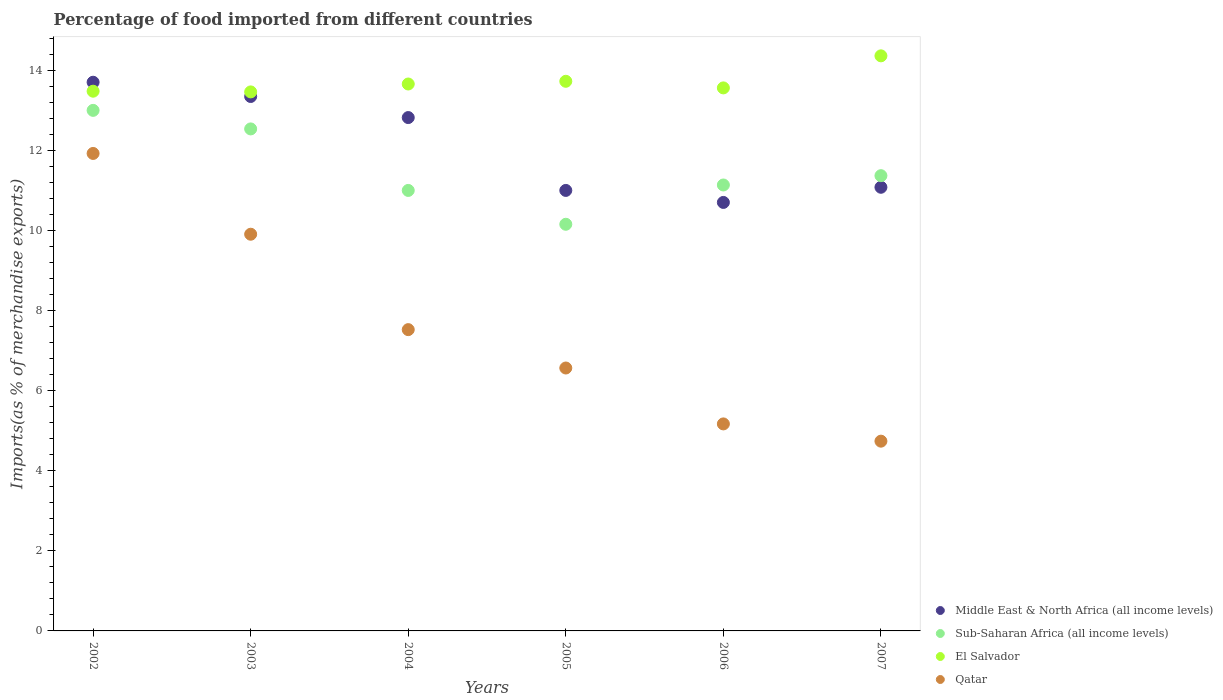How many different coloured dotlines are there?
Your response must be concise. 4. Is the number of dotlines equal to the number of legend labels?
Give a very brief answer. Yes. What is the percentage of imports to different countries in Sub-Saharan Africa (all income levels) in 2003?
Ensure brevity in your answer.  12.55. Across all years, what is the maximum percentage of imports to different countries in Middle East & North Africa (all income levels)?
Provide a short and direct response. 13.72. Across all years, what is the minimum percentage of imports to different countries in Sub-Saharan Africa (all income levels)?
Give a very brief answer. 10.17. What is the total percentage of imports to different countries in Middle East & North Africa (all income levels) in the graph?
Keep it short and to the point. 72.73. What is the difference between the percentage of imports to different countries in Sub-Saharan Africa (all income levels) in 2005 and that in 2007?
Keep it short and to the point. -1.21. What is the difference between the percentage of imports to different countries in Sub-Saharan Africa (all income levels) in 2004 and the percentage of imports to different countries in Qatar in 2003?
Ensure brevity in your answer.  1.1. What is the average percentage of imports to different countries in Qatar per year?
Your response must be concise. 7.65. In the year 2003, what is the difference between the percentage of imports to different countries in Qatar and percentage of imports to different countries in Sub-Saharan Africa (all income levels)?
Provide a short and direct response. -2.63. What is the ratio of the percentage of imports to different countries in El Salvador in 2004 to that in 2006?
Your answer should be very brief. 1.01. Is the difference between the percentage of imports to different countries in Qatar in 2002 and 2004 greater than the difference between the percentage of imports to different countries in Sub-Saharan Africa (all income levels) in 2002 and 2004?
Keep it short and to the point. Yes. What is the difference between the highest and the second highest percentage of imports to different countries in Qatar?
Your answer should be very brief. 2.02. What is the difference between the highest and the lowest percentage of imports to different countries in Qatar?
Provide a short and direct response. 7.19. Is it the case that in every year, the sum of the percentage of imports to different countries in El Salvador and percentage of imports to different countries in Sub-Saharan Africa (all income levels)  is greater than the sum of percentage of imports to different countries in Qatar and percentage of imports to different countries in Middle East & North Africa (all income levels)?
Ensure brevity in your answer.  No. Is it the case that in every year, the sum of the percentage of imports to different countries in Sub-Saharan Africa (all income levels) and percentage of imports to different countries in Middle East & North Africa (all income levels)  is greater than the percentage of imports to different countries in Qatar?
Offer a terse response. Yes. Does the percentage of imports to different countries in El Salvador monotonically increase over the years?
Make the answer very short. No. How many dotlines are there?
Your answer should be compact. 4. What is the difference between two consecutive major ticks on the Y-axis?
Offer a terse response. 2. Does the graph contain any zero values?
Provide a short and direct response. No. Where does the legend appear in the graph?
Your response must be concise. Bottom right. What is the title of the graph?
Provide a succinct answer. Percentage of food imported from different countries. Does "Brazil" appear as one of the legend labels in the graph?
Your response must be concise. No. What is the label or title of the Y-axis?
Give a very brief answer. Imports(as % of merchandise exports). What is the Imports(as % of merchandise exports) in Middle East & North Africa (all income levels) in 2002?
Your answer should be compact. 13.72. What is the Imports(as % of merchandise exports) of Sub-Saharan Africa (all income levels) in 2002?
Keep it short and to the point. 13.01. What is the Imports(as % of merchandise exports) in El Salvador in 2002?
Provide a short and direct response. 13.49. What is the Imports(as % of merchandise exports) in Qatar in 2002?
Your answer should be very brief. 11.94. What is the Imports(as % of merchandise exports) in Middle East & North Africa (all income levels) in 2003?
Give a very brief answer. 13.36. What is the Imports(as % of merchandise exports) of Sub-Saharan Africa (all income levels) in 2003?
Your answer should be very brief. 12.55. What is the Imports(as % of merchandise exports) of El Salvador in 2003?
Make the answer very short. 13.48. What is the Imports(as % of merchandise exports) in Qatar in 2003?
Offer a terse response. 9.92. What is the Imports(as % of merchandise exports) in Middle East & North Africa (all income levels) in 2004?
Provide a short and direct response. 12.83. What is the Imports(as % of merchandise exports) of Sub-Saharan Africa (all income levels) in 2004?
Provide a succinct answer. 11.01. What is the Imports(as % of merchandise exports) in El Salvador in 2004?
Provide a succinct answer. 13.67. What is the Imports(as % of merchandise exports) in Qatar in 2004?
Give a very brief answer. 7.53. What is the Imports(as % of merchandise exports) of Middle East & North Africa (all income levels) in 2005?
Give a very brief answer. 11.01. What is the Imports(as % of merchandise exports) of Sub-Saharan Africa (all income levels) in 2005?
Your answer should be very brief. 10.17. What is the Imports(as % of merchandise exports) in El Salvador in 2005?
Ensure brevity in your answer.  13.74. What is the Imports(as % of merchandise exports) of Qatar in 2005?
Make the answer very short. 6.57. What is the Imports(as % of merchandise exports) in Middle East & North Africa (all income levels) in 2006?
Provide a short and direct response. 10.71. What is the Imports(as % of merchandise exports) of Sub-Saharan Africa (all income levels) in 2006?
Offer a terse response. 11.15. What is the Imports(as % of merchandise exports) of El Salvador in 2006?
Provide a short and direct response. 13.58. What is the Imports(as % of merchandise exports) in Qatar in 2006?
Ensure brevity in your answer.  5.18. What is the Imports(as % of merchandise exports) of Middle East & North Africa (all income levels) in 2007?
Offer a very short reply. 11.09. What is the Imports(as % of merchandise exports) in Sub-Saharan Africa (all income levels) in 2007?
Provide a succinct answer. 11.38. What is the Imports(as % of merchandise exports) of El Salvador in 2007?
Ensure brevity in your answer.  14.38. What is the Imports(as % of merchandise exports) of Qatar in 2007?
Keep it short and to the point. 4.74. Across all years, what is the maximum Imports(as % of merchandise exports) in Middle East & North Africa (all income levels)?
Your response must be concise. 13.72. Across all years, what is the maximum Imports(as % of merchandise exports) in Sub-Saharan Africa (all income levels)?
Your answer should be compact. 13.01. Across all years, what is the maximum Imports(as % of merchandise exports) in El Salvador?
Your response must be concise. 14.38. Across all years, what is the maximum Imports(as % of merchandise exports) of Qatar?
Make the answer very short. 11.94. Across all years, what is the minimum Imports(as % of merchandise exports) of Middle East & North Africa (all income levels)?
Your answer should be compact. 10.71. Across all years, what is the minimum Imports(as % of merchandise exports) of Sub-Saharan Africa (all income levels)?
Give a very brief answer. 10.17. Across all years, what is the minimum Imports(as % of merchandise exports) in El Salvador?
Make the answer very short. 13.48. Across all years, what is the minimum Imports(as % of merchandise exports) in Qatar?
Give a very brief answer. 4.74. What is the total Imports(as % of merchandise exports) of Middle East & North Africa (all income levels) in the graph?
Your response must be concise. 72.73. What is the total Imports(as % of merchandise exports) in Sub-Saharan Africa (all income levels) in the graph?
Offer a very short reply. 69.27. What is the total Imports(as % of merchandise exports) in El Salvador in the graph?
Provide a short and direct response. 82.33. What is the total Imports(as % of merchandise exports) in Qatar in the graph?
Make the answer very short. 45.88. What is the difference between the Imports(as % of merchandise exports) in Middle East & North Africa (all income levels) in 2002 and that in 2003?
Give a very brief answer. 0.36. What is the difference between the Imports(as % of merchandise exports) of Sub-Saharan Africa (all income levels) in 2002 and that in 2003?
Ensure brevity in your answer.  0.46. What is the difference between the Imports(as % of merchandise exports) of El Salvador in 2002 and that in 2003?
Your answer should be compact. 0.02. What is the difference between the Imports(as % of merchandise exports) of Qatar in 2002 and that in 2003?
Keep it short and to the point. 2.02. What is the difference between the Imports(as % of merchandise exports) in Middle East & North Africa (all income levels) in 2002 and that in 2004?
Offer a very short reply. 0.88. What is the difference between the Imports(as % of merchandise exports) in Sub-Saharan Africa (all income levels) in 2002 and that in 2004?
Ensure brevity in your answer.  2. What is the difference between the Imports(as % of merchandise exports) of El Salvador in 2002 and that in 2004?
Make the answer very short. -0.18. What is the difference between the Imports(as % of merchandise exports) of Qatar in 2002 and that in 2004?
Keep it short and to the point. 4.4. What is the difference between the Imports(as % of merchandise exports) in Middle East & North Africa (all income levels) in 2002 and that in 2005?
Give a very brief answer. 2.7. What is the difference between the Imports(as % of merchandise exports) of Sub-Saharan Africa (all income levels) in 2002 and that in 2005?
Make the answer very short. 2.85. What is the difference between the Imports(as % of merchandise exports) in El Salvador in 2002 and that in 2005?
Offer a terse response. -0.25. What is the difference between the Imports(as % of merchandise exports) in Qatar in 2002 and that in 2005?
Offer a very short reply. 5.36. What is the difference between the Imports(as % of merchandise exports) in Middle East & North Africa (all income levels) in 2002 and that in 2006?
Your response must be concise. 3. What is the difference between the Imports(as % of merchandise exports) in Sub-Saharan Africa (all income levels) in 2002 and that in 2006?
Provide a short and direct response. 1.87. What is the difference between the Imports(as % of merchandise exports) in El Salvador in 2002 and that in 2006?
Offer a very short reply. -0.08. What is the difference between the Imports(as % of merchandise exports) in Qatar in 2002 and that in 2006?
Provide a short and direct response. 6.76. What is the difference between the Imports(as % of merchandise exports) of Middle East & North Africa (all income levels) in 2002 and that in 2007?
Your response must be concise. 2.63. What is the difference between the Imports(as % of merchandise exports) of Sub-Saharan Africa (all income levels) in 2002 and that in 2007?
Offer a terse response. 1.63. What is the difference between the Imports(as % of merchandise exports) in El Salvador in 2002 and that in 2007?
Offer a terse response. -0.88. What is the difference between the Imports(as % of merchandise exports) in Qatar in 2002 and that in 2007?
Your response must be concise. 7.19. What is the difference between the Imports(as % of merchandise exports) of Middle East & North Africa (all income levels) in 2003 and that in 2004?
Offer a terse response. 0.53. What is the difference between the Imports(as % of merchandise exports) in Sub-Saharan Africa (all income levels) in 2003 and that in 2004?
Offer a very short reply. 1.54. What is the difference between the Imports(as % of merchandise exports) in El Salvador in 2003 and that in 2004?
Make the answer very short. -0.2. What is the difference between the Imports(as % of merchandise exports) in Qatar in 2003 and that in 2004?
Give a very brief answer. 2.39. What is the difference between the Imports(as % of merchandise exports) of Middle East & North Africa (all income levels) in 2003 and that in 2005?
Keep it short and to the point. 2.35. What is the difference between the Imports(as % of merchandise exports) of Sub-Saharan Africa (all income levels) in 2003 and that in 2005?
Provide a succinct answer. 2.38. What is the difference between the Imports(as % of merchandise exports) in El Salvador in 2003 and that in 2005?
Offer a terse response. -0.27. What is the difference between the Imports(as % of merchandise exports) in Qatar in 2003 and that in 2005?
Offer a terse response. 3.34. What is the difference between the Imports(as % of merchandise exports) of Middle East & North Africa (all income levels) in 2003 and that in 2006?
Ensure brevity in your answer.  2.65. What is the difference between the Imports(as % of merchandise exports) of Sub-Saharan Africa (all income levels) in 2003 and that in 2006?
Provide a short and direct response. 1.4. What is the difference between the Imports(as % of merchandise exports) of El Salvador in 2003 and that in 2006?
Provide a short and direct response. -0.1. What is the difference between the Imports(as % of merchandise exports) in Qatar in 2003 and that in 2006?
Provide a succinct answer. 4.74. What is the difference between the Imports(as % of merchandise exports) in Middle East & North Africa (all income levels) in 2003 and that in 2007?
Provide a succinct answer. 2.27. What is the difference between the Imports(as % of merchandise exports) in Sub-Saharan Africa (all income levels) in 2003 and that in 2007?
Offer a terse response. 1.17. What is the difference between the Imports(as % of merchandise exports) in El Salvador in 2003 and that in 2007?
Keep it short and to the point. -0.9. What is the difference between the Imports(as % of merchandise exports) of Qatar in 2003 and that in 2007?
Provide a short and direct response. 5.17. What is the difference between the Imports(as % of merchandise exports) in Middle East & North Africa (all income levels) in 2004 and that in 2005?
Give a very brief answer. 1.82. What is the difference between the Imports(as % of merchandise exports) in Sub-Saharan Africa (all income levels) in 2004 and that in 2005?
Your answer should be compact. 0.85. What is the difference between the Imports(as % of merchandise exports) of El Salvador in 2004 and that in 2005?
Offer a very short reply. -0.07. What is the difference between the Imports(as % of merchandise exports) of Qatar in 2004 and that in 2005?
Keep it short and to the point. 0.96. What is the difference between the Imports(as % of merchandise exports) in Middle East & North Africa (all income levels) in 2004 and that in 2006?
Provide a short and direct response. 2.12. What is the difference between the Imports(as % of merchandise exports) in Sub-Saharan Africa (all income levels) in 2004 and that in 2006?
Provide a short and direct response. -0.14. What is the difference between the Imports(as % of merchandise exports) in El Salvador in 2004 and that in 2006?
Provide a succinct answer. 0.1. What is the difference between the Imports(as % of merchandise exports) in Qatar in 2004 and that in 2006?
Ensure brevity in your answer.  2.36. What is the difference between the Imports(as % of merchandise exports) in Middle East & North Africa (all income levels) in 2004 and that in 2007?
Offer a terse response. 1.74. What is the difference between the Imports(as % of merchandise exports) in Sub-Saharan Africa (all income levels) in 2004 and that in 2007?
Your answer should be compact. -0.37. What is the difference between the Imports(as % of merchandise exports) in El Salvador in 2004 and that in 2007?
Offer a very short reply. -0.7. What is the difference between the Imports(as % of merchandise exports) of Qatar in 2004 and that in 2007?
Make the answer very short. 2.79. What is the difference between the Imports(as % of merchandise exports) in Middle East & North Africa (all income levels) in 2005 and that in 2006?
Keep it short and to the point. 0.3. What is the difference between the Imports(as % of merchandise exports) in Sub-Saharan Africa (all income levels) in 2005 and that in 2006?
Provide a succinct answer. -0.98. What is the difference between the Imports(as % of merchandise exports) of El Salvador in 2005 and that in 2006?
Give a very brief answer. 0.17. What is the difference between the Imports(as % of merchandise exports) in Qatar in 2005 and that in 2006?
Give a very brief answer. 1.4. What is the difference between the Imports(as % of merchandise exports) in Middle East & North Africa (all income levels) in 2005 and that in 2007?
Keep it short and to the point. -0.08. What is the difference between the Imports(as % of merchandise exports) of Sub-Saharan Africa (all income levels) in 2005 and that in 2007?
Your response must be concise. -1.21. What is the difference between the Imports(as % of merchandise exports) in El Salvador in 2005 and that in 2007?
Make the answer very short. -0.64. What is the difference between the Imports(as % of merchandise exports) in Qatar in 2005 and that in 2007?
Provide a short and direct response. 1.83. What is the difference between the Imports(as % of merchandise exports) of Middle East & North Africa (all income levels) in 2006 and that in 2007?
Your answer should be compact. -0.38. What is the difference between the Imports(as % of merchandise exports) of Sub-Saharan Africa (all income levels) in 2006 and that in 2007?
Your answer should be compact. -0.23. What is the difference between the Imports(as % of merchandise exports) of El Salvador in 2006 and that in 2007?
Provide a succinct answer. -0.8. What is the difference between the Imports(as % of merchandise exports) in Qatar in 2006 and that in 2007?
Make the answer very short. 0.43. What is the difference between the Imports(as % of merchandise exports) in Middle East & North Africa (all income levels) in 2002 and the Imports(as % of merchandise exports) in Sub-Saharan Africa (all income levels) in 2003?
Keep it short and to the point. 1.17. What is the difference between the Imports(as % of merchandise exports) in Middle East & North Africa (all income levels) in 2002 and the Imports(as % of merchandise exports) in El Salvador in 2003?
Ensure brevity in your answer.  0.24. What is the difference between the Imports(as % of merchandise exports) in Middle East & North Africa (all income levels) in 2002 and the Imports(as % of merchandise exports) in Qatar in 2003?
Provide a succinct answer. 3.8. What is the difference between the Imports(as % of merchandise exports) of Sub-Saharan Africa (all income levels) in 2002 and the Imports(as % of merchandise exports) of El Salvador in 2003?
Provide a short and direct response. -0.46. What is the difference between the Imports(as % of merchandise exports) of Sub-Saharan Africa (all income levels) in 2002 and the Imports(as % of merchandise exports) of Qatar in 2003?
Make the answer very short. 3.1. What is the difference between the Imports(as % of merchandise exports) in El Salvador in 2002 and the Imports(as % of merchandise exports) in Qatar in 2003?
Your answer should be compact. 3.58. What is the difference between the Imports(as % of merchandise exports) of Middle East & North Africa (all income levels) in 2002 and the Imports(as % of merchandise exports) of Sub-Saharan Africa (all income levels) in 2004?
Ensure brevity in your answer.  2.7. What is the difference between the Imports(as % of merchandise exports) of Middle East & North Africa (all income levels) in 2002 and the Imports(as % of merchandise exports) of El Salvador in 2004?
Your response must be concise. 0.04. What is the difference between the Imports(as % of merchandise exports) of Middle East & North Africa (all income levels) in 2002 and the Imports(as % of merchandise exports) of Qatar in 2004?
Your response must be concise. 6.18. What is the difference between the Imports(as % of merchandise exports) in Sub-Saharan Africa (all income levels) in 2002 and the Imports(as % of merchandise exports) in El Salvador in 2004?
Give a very brief answer. -0.66. What is the difference between the Imports(as % of merchandise exports) of Sub-Saharan Africa (all income levels) in 2002 and the Imports(as % of merchandise exports) of Qatar in 2004?
Make the answer very short. 5.48. What is the difference between the Imports(as % of merchandise exports) of El Salvador in 2002 and the Imports(as % of merchandise exports) of Qatar in 2004?
Make the answer very short. 5.96. What is the difference between the Imports(as % of merchandise exports) in Middle East & North Africa (all income levels) in 2002 and the Imports(as % of merchandise exports) in Sub-Saharan Africa (all income levels) in 2005?
Your answer should be very brief. 3.55. What is the difference between the Imports(as % of merchandise exports) of Middle East & North Africa (all income levels) in 2002 and the Imports(as % of merchandise exports) of El Salvador in 2005?
Your answer should be very brief. -0.02. What is the difference between the Imports(as % of merchandise exports) of Middle East & North Africa (all income levels) in 2002 and the Imports(as % of merchandise exports) of Qatar in 2005?
Provide a succinct answer. 7.14. What is the difference between the Imports(as % of merchandise exports) of Sub-Saharan Africa (all income levels) in 2002 and the Imports(as % of merchandise exports) of El Salvador in 2005?
Give a very brief answer. -0.73. What is the difference between the Imports(as % of merchandise exports) in Sub-Saharan Africa (all income levels) in 2002 and the Imports(as % of merchandise exports) in Qatar in 2005?
Provide a succinct answer. 6.44. What is the difference between the Imports(as % of merchandise exports) of El Salvador in 2002 and the Imports(as % of merchandise exports) of Qatar in 2005?
Your answer should be very brief. 6.92. What is the difference between the Imports(as % of merchandise exports) of Middle East & North Africa (all income levels) in 2002 and the Imports(as % of merchandise exports) of Sub-Saharan Africa (all income levels) in 2006?
Offer a very short reply. 2.57. What is the difference between the Imports(as % of merchandise exports) of Middle East & North Africa (all income levels) in 2002 and the Imports(as % of merchandise exports) of El Salvador in 2006?
Give a very brief answer. 0.14. What is the difference between the Imports(as % of merchandise exports) of Middle East & North Africa (all income levels) in 2002 and the Imports(as % of merchandise exports) of Qatar in 2006?
Provide a succinct answer. 8.54. What is the difference between the Imports(as % of merchandise exports) of Sub-Saharan Africa (all income levels) in 2002 and the Imports(as % of merchandise exports) of El Salvador in 2006?
Your answer should be compact. -0.56. What is the difference between the Imports(as % of merchandise exports) in Sub-Saharan Africa (all income levels) in 2002 and the Imports(as % of merchandise exports) in Qatar in 2006?
Your answer should be compact. 7.84. What is the difference between the Imports(as % of merchandise exports) in El Salvador in 2002 and the Imports(as % of merchandise exports) in Qatar in 2006?
Your response must be concise. 8.32. What is the difference between the Imports(as % of merchandise exports) of Middle East & North Africa (all income levels) in 2002 and the Imports(as % of merchandise exports) of Sub-Saharan Africa (all income levels) in 2007?
Ensure brevity in your answer.  2.34. What is the difference between the Imports(as % of merchandise exports) of Middle East & North Africa (all income levels) in 2002 and the Imports(as % of merchandise exports) of El Salvador in 2007?
Provide a short and direct response. -0.66. What is the difference between the Imports(as % of merchandise exports) of Middle East & North Africa (all income levels) in 2002 and the Imports(as % of merchandise exports) of Qatar in 2007?
Make the answer very short. 8.97. What is the difference between the Imports(as % of merchandise exports) in Sub-Saharan Africa (all income levels) in 2002 and the Imports(as % of merchandise exports) in El Salvador in 2007?
Keep it short and to the point. -1.36. What is the difference between the Imports(as % of merchandise exports) in Sub-Saharan Africa (all income levels) in 2002 and the Imports(as % of merchandise exports) in Qatar in 2007?
Your answer should be compact. 8.27. What is the difference between the Imports(as % of merchandise exports) in El Salvador in 2002 and the Imports(as % of merchandise exports) in Qatar in 2007?
Keep it short and to the point. 8.75. What is the difference between the Imports(as % of merchandise exports) of Middle East & North Africa (all income levels) in 2003 and the Imports(as % of merchandise exports) of Sub-Saharan Africa (all income levels) in 2004?
Your answer should be very brief. 2.35. What is the difference between the Imports(as % of merchandise exports) of Middle East & North Africa (all income levels) in 2003 and the Imports(as % of merchandise exports) of El Salvador in 2004?
Ensure brevity in your answer.  -0.31. What is the difference between the Imports(as % of merchandise exports) of Middle East & North Africa (all income levels) in 2003 and the Imports(as % of merchandise exports) of Qatar in 2004?
Provide a short and direct response. 5.83. What is the difference between the Imports(as % of merchandise exports) of Sub-Saharan Africa (all income levels) in 2003 and the Imports(as % of merchandise exports) of El Salvador in 2004?
Your answer should be compact. -1.12. What is the difference between the Imports(as % of merchandise exports) in Sub-Saharan Africa (all income levels) in 2003 and the Imports(as % of merchandise exports) in Qatar in 2004?
Offer a very short reply. 5.02. What is the difference between the Imports(as % of merchandise exports) in El Salvador in 2003 and the Imports(as % of merchandise exports) in Qatar in 2004?
Make the answer very short. 5.94. What is the difference between the Imports(as % of merchandise exports) in Middle East & North Africa (all income levels) in 2003 and the Imports(as % of merchandise exports) in Sub-Saharan Africa (all income levels) in 2005?
Give a very brief answer. 3.19. What is the difference between the Imports(as % of merchandise exports) in Middle East & North Africa (all income levels) in 2003 and the Imports(as % of merchandise exports) in El Salvador in 2005?
Make the answer very short. -0.38. What is the difference between the Imports(as % of merchandise exports) in Middle East & North Africa (all income levels) in 2003 and the Imports(as % of merchandise exports) in Qatar in 2005?
Offer a very short reply. 6.79. What is the difference between the Imports(as % of merchandise exports) of Sub-Saharan Africa (all income levels) in 2003 and the Imports(as % of merchandise exports) of El Salvador in 2005?
Provide a succinct answer. -1.19. What is the difference between the Imports(as % of merchandise exports) of Sub-Saharan Africa (all income levels) in 2003 and the Imports(as % of merchandise exports) of Qatar in 2005?
Ensure brevity in your answer.  5.98. What is the difference between the Imports(as % of merchandise exports) in El Salvador in 2003 and the Imports(as % of merchandise exports) in Qatar in 2005?
Make the answer very short. 6.9. What is the difference between the Imports(as % of merchandise exports) in Middle East & North Africa (all income levels) in 2003 and the Imports(as % of merchandise exports) in Sub-Saharan Africa (all income levels) in 2006?
Your answer should be compact. 2.21. What is the difference between the Imports(as % of merchandise exports) in Middle East & North Africa (all income levels) in 2003 and the Imports(as % of merchandise exports) in El Salvador in 2006?
Your answer should be compact. -0.21. What is the difference between the Imports(as % of merchandise exports) of Middle East & North Africa (all income levels) in 2003 and the Imports(as % of merchandise exports) of Qatar in 2006?
Offer a terse response. 8.19. What is the difference between the Imports(as % of merchandise exports) of Sub-Saharan Africa (all income levels) in 2003 and the Imports(as % of merchandise exports) of El Salvador in 2006?
Offer a terse response. -1.03. What is the difference between the Imports(as % of merchandise exports) in Sub-Saharan Africa (all income levels) in 2003 and the Imports(as % of merchandise exports) in Qatar in 2006?
Your response must be concise. 7.38. What is the difference between the Imports(as % of merchandise exports) in El Salvador in 2003 and the Imports(as % of merchandise exports) in Qatar in 2006?
Provide a short and direct response. 8.3. What is the difference between the Imports(as % of merchandise exports) in Middle East & North Africa (all income levels) in 2003 and the Imports(as % of merchandise exports) in Sub-Saharan Africa (all income levels) in 2007?
Keep it short and to the point. 1.98. What is the difference between the Imports(as % of merchandise exports) in Middle East & North Africa (all income levels) in 2003 and the Imports(as % of merchandise exports) in El Salvador in 2007?
Offer a very short reply. -1.02. What is the difference between the Imports(as % of merchandise exports) in Middle East & North Africa (all income levels) in 2003 and the Imports(as % of merchandise exports) in Qatar in 2007?
Your answer should be very brief. 8.62. What is the difference between the Imports(as % of merchandise exports) in Sub-Saharan Africa (all income levels) in 2003 and the Imports(as % of merchandise exports) in El Salvador in 2007?
Your answer should be compact. -1.83. What is the difference between the Imports(as % of merchandise exports) of Sub-Saharan Africa (all income levels) in 2003 and the Imports(as % of merchandise exports) of Qatar in 2007?
Provide a succinct answer. 7.81. What is the difference between the Imports(as % of merchandise exports) of El Salvador in 2003 and the Imports(as % of merchandise exports) of Qatar in 2007?
Give a very brief answer. 8.73. What is the difference between the Imports(as % of merchandise exports) of Middle East & North Africa (all income levels) in 2004 and the Imports(as % of merchandise exports) of Sub-Saharan Africa (all income levels) in 2005?
Make the answer very short. 2.67. What is the difference between the Imports(as % of merchandise exports) of Middle East & North Africa (all income levels) in 2004 and the Imports(as % of merchandise exports) of El Salvador in 2005?
Provide a succinct answer. -0.91. What is the difference between the Imports(as % of merchandise exports) in Middle East & North Africa (all income levels) in 2004 and the Imports(as % of merchandise exports) in Qatar in 2005?
Offer a very short reply. 6.26. What is the difference between the Imports(as % of merchandise exports) of Sub-Saharan Africa (all income levels) in 2004 and the Imports(as % of merchandise exports) of El Salvador in 2005?
Make the answer very short. -2.73. What is the difference between the Imports(as % of merchandise exports) of Sub-Saharan Africa (all income levels) in 2004 and the Imports(as % of merchandise exports) of Qatar in 2005?
Ensure brevity in your answer.  4.44. What is the difference between the Imports(as % of merchandise exports) of El Salvador in 2004 and the Imports(as % of merchandise exports) of Qatar in 2005?
Offer a terse response. 7.1. What is the difference between the Imports(as % of merchandise exports) of Middle East & North Africa (all income levels) in 2004 and the Imports(as % of merchandise exports) of Sub-Saharan Africa (all income levels) in 2006?
Ensure brevity in your answer.  1.69. What is the difference between the Imports(as % of merchandise exports) of Middle East & North Africa (all income levels) in 2004 and the Imports(as % of merchandise exports) of El Salvador in 2006?
Offer a terse response. -0.74. What is the difference between the Imports(as % of merchandise exports) of Middle East & North Africa (all income levels) in 2004 and the Imports(as % of merchandise exports) of Qatar in 2006?
Your response must be concise. 7.66. What is the difference between the Imports(as % of merchandise exports) of Sub-Saharan Africa (all income levels) in 2004 and the Imports(as % of merchandise exports) of El Salvador in 2006?
Give a very brief answer. -2.56. What is the difference between the Imports(as % of merchandise exports) of Sub-Saharan Africa (all income levels) in 2004 and the Imports(as % of merchandise exports) of Qatar in 2006?
Give a very brief answer. 5.84. What is the difference between the Imports(as % of merchandise exports) in El Salvador in 2004 and the Imports(as % of merchandise exports) in Qatar in 2006?
Provide a succinct answer. 8.5. What is the difference between the Imports(as % of merchandise exports) of Middle East & North Africa (all income levels) in 2004 and the Imports(as % of merchandise exports) of Sub-Saharan Africa (all income levels) in 2007?
Your answer should be compact. 1.45. What is the difference between the Imports(as % of merchandise exports) in Middle East & North Africa (all income levels) in 2004 and the Imports(as % of merchandise exports) in El Salvador in 2007?
Make the answer very short. -1.54. What is the difference between the Imports(as % of merchandise exports) of Middle East & North Africa (all income levels) in 2004 and the Imports(as % of merchandise exports) of Qatar in 2007?
Offer a terse response. 8.09. What is the difference between the Imports(as % of merchandise exports) in Sub-Saharan Africa (all income levels) in 2004 and the Imports(as % of merchandise exports) in El Salvador in 2007?
Offer a very short reply. -3.36. What is the difference between the Imports(as % of merchandise exports) of Sub-Saharan Africa (all income levels) in 2004 and the Imports(as % of merchandise exports) of Qatar in 2007?
Your answer should be very brief. 6.27. What is the difference between the Imports(as % of merchandise exports) of El Salvador in 2004 and the Imports(as % of merchandise exports) of Qatar in 2007?
Your answer should be compact. 8.93. What is the difference between the Imports(as % of merchandise exports) of Middle East & North Africa (all income levels) in 2005 and the Imports(as % of merchandise exports) of Sub-Saharan Africa (all income levels) in 2006?
Ensure brevity in your answer.  -0.14. What is the difference between the Imports(as % of merchandise exports) in Middle East & North Africa (all income levels) in 2005 and the Imports(as % of merchandise exports) in El Salvador in 2006?
Offer a terse response. -2.56. What is the difference between the Imports(as % of merchandise exports) in Middle East & North Africa (all income levels) in 2005 and the Imports(as % of merchandise exports) in Qatar in 2006?
Provide a short and direct response. 5.84. What is the difference between the Imports(as % of merchandise exports) in Sub-Saharan Africa (all income levels) in 2005 and the Imports(as % of merchandise exports) in El Salvador in 2006?
Give a very brief answer. -3.41. What is the difference between the Imports(as % of merchandise exports) in Sub-Saharan Africa (all income levels) in 2005 and the Imports(as % of merchandise exports) in Qatar in 2006?
Give a very brief answer. 4.99. What is the difference between the Imports(as % of merchandise exports) in El Salvador in 2005 and the Imports(as % of merchandise exports) in Qatar in 2006?
Offer a terse response. 8.57. What is the difference between the Imports(as % of merchandise exports) in Middle East & North Africa (all income levels) in 2005 and the Imports(as % of merchandise exports) in Sub-Saharan Africa (all income levels) in 2007?
Keep it short and to the point. -0.37. What is the difference between the Imports(as % of merchandise exports) of Middle East & North Africa (all income levels) in 2005 and the Imports(as % of merchandise exports) of El Salvador in 2007?
Make the answer very short. -3.36. What is the difference between the Imports(as % of merchandise exports) of Middle East & North Africa (all income levels) in 2005 and the Imports(as % of merchandise exports) of Qatar in 2007?
Your answer should be very brief. 6.27. What is the difference between the Imports(as % of merchandise exports) in Sub-Saharan Africa (all income levels) in 2005 and the Imports(as % of merchandise exports) in El Salvador in 2007?
Provide a short and direct response. -4.21. What is the difference between the Imports(as % of merchandise exports) in Sub-Saharan Africa (all income levels) in 2005 and the Imports(as % of merchandise exports) in Qatar in 2007?
Your response must be concise. 5.42. What is the difference between the Imports(as % of merchandise exports) of El Salvador in 2005 and the Imports(as % of merchandise exports) of Qatar in 2007?
Your response must be concise. 9. What is the difference between the Imports(as % of merchandise exports) in Middle East & North Africa (all income levels) in 2006 and the Imports(as % of merchandise exports) in Sub-Saharan Africa (all income levels) in 2007?
Make the answer very short. -0.67. What is the difference between the Imports(as % of merchandise exports) of Middle East & North Africa (all income levels) in 2006 and the Imports(as % of merchandise exports) of El Salvador in 2007?
Provide a short and direct response. -3.66. What is the difference between the Imports(as % of merchandise exports) in Middle East & North Africa (all income levels) in 2006 and the Imports(as % of merchandise exports) in Qatar in 2007?
Provide a succinct answer. 5.97. What is the difference between the Imports(as % of merchandise exports) in Sub-Saharan Africa (all income levels) in 2006 and the Imports(as % of merchandise exports) in El Salvador in 2007?
Your answer should be very brief. -3.23. What is the difference between the Imports(as % of merchandise exports) of Sub-Saharan Africa (all income levels) in 2006 and the Imports(as % of merchandise exports) of Qatar in 2007?
Make the answer very short. 6.4. What is the difference between the Imports(as % of merchandise exports) in El Salvador in 2006 and the Imports(as % of merchandise exports) in Qatar in 2007?
Your answer should be very brief. 8.83. What is the average Imports(as % of merchandise exports) in Middle East & North Africa (all income levels) per year?
Your answer should be compact. 12.12. What is the average Imports(as % of merchandise exports) in Sub-Saharan Africa (all income levels) per year?
Your response must be concise. 11.55. What is the average Imports(as % of merchandise exports) of El Salvador per year?
Provide a short and direct response. 13.72. What is the average Imports(as % of merchandise exports) in Qatar per year?
Offer a terse response. 7.65. In the year 2002, what is the difference between the Imports(as % of merchandise exports) in Middle East & North Africa (all income levels) and Imports(as % of merchandise exports) in Sub-Saharan Africa (all income levels)?
Ensure brevity in your answer.  0.7. In the year 2002, what is the difference between the Imports(as % of merchandise exports) in Middle East & North Africa (all income levels) and Imports(as % of merchandise exports) in El Salvador?
Provide a short and direct response. 0.22. In the year 2002, what is the difference between the Imports(as % of merchandise exports) in Middle East & North Africa (all income levels) and Imports(as % of merchandise exports) in Qatar?
Your answer should be very brief. 1.78. In the year 2002, what is the difference between the Imports(as % of merchandise exports) of Sub-Saharan Africa (all income levels) and Imports(as % of merchandise exports) of El Salvador?
Provide a succinct answer. -0.48. In the year 2002, what is the difference between the Imports(as % of merchandise exports) in Sub-Saharan Africa (all income levels) and Imports(as % of merchandise exports) in Qatar?
Keep it short and to the point. 1.08. In the year 2002, what is the difference between the Imports(as % of merchandise exports) of El Salvador and Imports(as % of merchandise exports) of Qatar?
Your answer should be compact. 1.56. In the year 2003, what is the difference between the Imports(as % of merchandise exports) in Middle East & North Africa (all income levels) and Imports(as % of merchandise exports) in Sub-Saharan Africa (all income levels)?
Provide a succinct answer. 0.81. In the year 2003, what is the difference between the Imports(as % of merchandise exports) in Middle East & North Africa (all income levels) and Imports(as % of merchandise exports) in El Salvador?
Your response must be concise. -0.11. In the year 2003, what is the difference between the Imports(as % of merchandise exports) in Middle East & North Africa (all income levels) and Imports(as % of merchandise exports) in Qatar?
Keep it short and to the point. 3.44. In the year 2003, what is the difference between the Imports(as % of merchandise exports) in Sub-Saharan Africa (all income levels) and Imports(as % of merchandise exports) in El Salvador?
Your answer should be compact. -0.93. In the year 2003, what is the difference between the Imports(as % of merchandise exports) in Sub-Saharan Africa (all income levels) and Imports(as % of merchandise exports) in Qatar?
Your answer should be very brief. 2.63. In the year 2003, what is the difference between the Imports(as % of merchandise exports) of El Salvador and Imports(as % of merchandise exports) of Qatar?
Your answer should be compact. 3.56. In the year 2004, what is the difference between the Imports(as % of merchandise exports) of Middle East & North Africa (all income levels) and Imports(as % of merchandise exports) of Sub-Saharan Africa (all income levels)?
Your answer should be very brief. 1.82. In the year 2004, what is the difference between the Imports(as % of merchandise exports) of Middle East & North Africa (all income levels) and Imports(as % of merchandise exports) of El Salvador?
Your answer should be very brief. -0.84. In the year 2004, what is the difference between the Imports(as % of merchandise exports) of Middle East & North Africa (all income levels) and Imports(as % of merchandise exports) of Qatar?
Offer a very short reply. 5.3. In the year 2004, what is the difference between the Imports(as % of merchandise exports) in Sub-Saharan Africa (all income levels) and Imports(as % of merchandise exports) in El Salvador?
Give a very brief answer. -2.66. In the year 2004, what is the difference between the Imports(as % of merchandise exports) in Sub-Saharan Africa (all income levels) and Imports(as % of merchandise exports) in Qatar?
Ensure brevity in your answer.  3.48. In the year 2004, what is the difference between the Imports(as % of merchandise exports) in El Salvador and Imports(as % of merchandise exports) in Qatar?
Make the answer very short. 6.14. In the year 2005, what is the difference between the Imports(as % of merchandise exports) of Middle East & North Africa (all income levels) and Imports(as % of merchandise exports) of Sub-Saharan Africa (all income levels)?
Provide a short and direct response. 0.85. In the year 2005, what is the difference between the Imports(as % of merchandise exports) in Middle East & North Africa (all income levels) and Imports(as % of merchandise exports) in El Salvador?
Provide a short and direct response. -2.73. In the year 2005, what is the difference between the Imports(as % of merchandise exports) in Middle East & North Africa (all income levels) and Imports(as % of merchandise exports) in Qatar?
Keep it short and to the point. 4.44. In the year 2005, what is the difference between the Imports(as % of merchandise exports) of Sub-Saharan Africa (all income levels) and Imports(as % of merchandise exports) of El Salvador?
Your answer should be compact. -3.57. In the year 2005, what is the difference between the Imports(as % of merchandise exports) in Sub-Saharan Africa (all income levels) and Imports(as % of merchandise exports) in Qatar?
Your response must be concise. 3.59. In the year 2005, what is the difference between the Imports(as % of merchandise exports) of El Salvador and Imports(as % of merchandise exports) of Qatar?
Offer a very short reply. 7.17. In the year 2006, what is the difference between the Imports(as % of merchandise exports) in Middle East & North Africa (all income levels) and Imports(as % of merchandise exports) in Sub-Saharan Africa (all income levels)?
Your answer should be very brief. -0.44. In the year 2006, what is the difference between the Imports(as % of merchandise exports) of Middle East & North Africa (all income levels) and Imports(as % of merchandise exports) of El Salvador?
Make the answer very short. -2.86. In the year 2006, what is the difference between the Imports(as % of merchandise exports) in Middle East & North Africa (all income levels) and Imports(as % of merchandise exports) in Qatar?
Offer a very short reply. 5.54. In the year 2006, what is the difference between the Imports(as % of merchandise exports) in Sub-Saharan Africa (all income levels) and Imports(as % of merchandise exports) in El Salvador?
Give a very brief answer. -2.43. In the year 2006, what is the difference between the Imports(as % of merchandise exports) of Sub-Saharan Africa (all income levels) and Imports(as % of merchandise exports) of Qatar?
Give a very brief answer. 5.97. In the year 2006, what is the difference between the Imports(as % of merchandise exports) in El Salvador and Imports(as % of merchandise exports) in Qatar?
Keep it short and to the point. 8.4. In the year 2007, what is the difference between the Imports(as % of merchandise exports) of Middle East & North Africa (all income levels) and Imports(as % of merchandise exports) of Sub-Saharan Africa (all income levels)?
Your response must be concise. -0.29. In the year 2007, what is the difference between the Imports(as % of merchandise exports) of Middle East & North Africa (all income levels) and Imports(as % of merchandise exports) of El Salvador?
Offer a very short reply. -3.29. In the year 2007, what is the difference between the Imports(as % of merchandise exports) of Middle East & North Africa (all income levels) and Imports(as % of merchandise exports) of Qatar?
Keep it short and to the point. 6.35. In the year 2007, what is the difference between the Imports(as % of merchandise exports) in Sub-Saharan Africa (all income levels) and Imports(as % of merchandise exports) in El Salvador?
Keep it short and to the point. -3. In the year 2007, what is the difference between the Imports(as % of merchandise exports) in Sub-Saharan Africa (all income levels) and Imports(as % of merchandise exports) in Qatar?
Give a very brief answer. 6.64. In the year 2007, what is the difference between the Imports(as % of merchandise exports) of El Salvador and Imports(as % of merchandise exports) of Qatar?
Your answer should be compact. 9.63. What is the ratio of the Imports(as % of merchandise exports) of Middle East & North Africa (all income levels) in 2002 to that in 2003?
Provide a succinct answer. 1.03. What is the ratio of the Imports(as % of merchandise exports) of Sub-Saharan Africa (all income levels) in 2002 to that in 2003?
Make the answer very short. 1.04. What is the ratio of the Imports(as % of merchandise exports) in El Salvador in 2002 to that in 2003?
Provide a succinct answer. 1. What is the ratio of the Imports(as % of merchandise exports) of Qatar in 2002 to that in 2003?
Your answer should be very brief. 1.2. What is the ratio of the Imports(as % of merchandise exports) of Middle East & North Africa (all income levels) in 2002 to that in 2004?
Offer a terse response. 1.07. What is the ratio of the Imports(as % of merchandise exports) in Sub-Saharan Africa (all income levels) in 2002 to that in 2004?
Your response must be concise. 1.18. What is the ratio of the Imports(as % of merchandise exports) of Qatar in 2002 to that in 2004?
Ensure brevity in your answer.  1.58. What is the ratio of the Imports(as % of merchandise exports) of Middle East & North Africa (all income levels) in 2002 to that in 2005?
Offer a terse response. 1.25. What is the ratio of the Imports(as % of merchandise exports) of Sub-Saharan Africa (all income levels) in 2002 to that in 2005?
Offer a very short reply. 1.28. What is the ratio of the Imports(as % of merchandise exports) in El Salvador in 2002 to that in 2005?
Keep it short and to the point. 0.98. What is the ratio of the Imports(as % of merchandise exports) in Qatar in 2002 to that in 2005?
Make the answer very short. 1.82. What is the ratio of the Imports(as % of merchandise exports) of Middle East & North Africa (all income levels) in 2002 to that in 2006?
Your answer should be compact. 1.28. What is the ratio of the Imports(as % of merchandise exports) of Sub-Saharan Africa (all income levels) in 2002 to that in 2006?
Make the answer very short. 1.17. What is the ratio of the Imports(as % of merchandise exports) in Qatar in 2002 to that in 2006?
Offer a terse response. 2.31. What is the ratio of the Imports(as % of merchandise exports) of Middle East & North Africa (all income levels) in 2002 to that in 2007?
Give a very brief answer. 1.24. What is the ratio of the Imports(as % of merchandise exports) in Sub-Saharan Africa (all income levels) in 2002 to that in 2007?
Provide a succinct answer. 1.14. What is the ratio of the Imports(as % of merchandise exports) in El Salvador in 2002 to that in 2007?
Your answer should be compact. 0.94. What is the ratio of the Imports(as % of merchandise exports) of Qatar in 2002 to that in 2007?
Your response must be concise. 2.52. What is the ratio of the Imports(as % of merchandise exports) in Middle East & North Africa (all income levels) in 2003 to that in 2004?
Offer a very short reply. 1.04. What is the ratio of the Imports(as % of merchandise exports) in Sub-Saharan Africa (all income levels) in 2003 to that in 2004?
Give a very brief answer. 1.14. What is the ratio of the Imports(as % of merchandise exports) in El Salvador in 2003 to that in 2004?
Your response must be concise. 0.99. What is the ratio of the Imports(as % of merchandise exports) in Qatar in 2003 to that in 2004?
Make the answer very short. 1.32. What is the ratio of the Imports(as % of merchandise exports) of Middle East & North Africa (all income levels) in 2003 to that in 2005?
Provide a succinct answer. 1.21. What is the ratio of the Imports(as % of merchandise exports) of Sub-Saharan Africa (all income levels) in 2003 to that in 2005?
Offer a terse response. 1.23. What is the ratio of the Imports(as % of merchandise exports) of El Salvador in 2003 to that in 2005?
Ensure brevity in your answer.  0.98. What is the ratio of the Imports(as % of merchandise exports) of Qatar in 2003 to that in 2005?
Make the answer very short. 1.51. What is the ratio of the Imports(as % of merchandise exports) in Middle East & North Africa (all income levels) in 2003 to that in 2006?
Your answer should be very brief. 1.25. What is the ratio of the Imports(as % of merchandise exports) of Sub-Saharan Africa (all income levels) in 2003 to that in 2006?
Give a very brief answer. 1.13. What is the ratio of the Imports(as % of merchandise exports) in Qatar in 2003 to that in 2006?
Ensure brevity in your answer.  1.92. What is the ratio of the Imports(as % of merchandise exports) of Middle East & North Africa (all income levels) in 2003 to that in 2007?
Your answer should be compact. 1.2. What is the ratio of the Imports(as % of merchandise exports) of Sub-Saharan Africa (all income levels) in 2003 to that in 2007?
Your response must be concise. 1.1. What is the ratio of the Imports(as % of merchandise exports) of El Salvador in 2003 to that in 2007?
Provide a short and direct response. 0.94. What is the ratio of the Imports(as % of merchandise exports) in Qatar in 2003 to that in 2007?
Your response must be concise. 2.09. What is the ratio of the Imports(as % of merchandise exports) in Middle East & North Africa (all income levels) in 2004 to that in 2005?
Ensure brevity in your answer.  1.17. What is the ratio of the Imports(as % of merchandise exports) of Sub-Saharan Africa (all income levels) in 2004 to that in 2005?
Ensure brevity in your answer.  1.08. What is the ratio of the Imports(as % of merchandise exports) in Qatar in 2004 to that in 2005?
Provide a short and direct response. 1.15. What is the ratio of the Imports(as % of merchandise exports) in Middle East & North Africa (all income levels) in 2004 to that in 2006?
Make the answer very short. 1.2. What is the ratio of the Imports(as % of merchandise exports) in Qatar in 2004 to that in 2006?
Ensure brevity in your answer.  1.46. What is the ratio of the Imports(as % of merchandise exports) in Middle East & North Africa (all income levels) in 2004 to that in 2007?
Offer a very short reply. 1.16. What is the ratio of the Imports(as % of merchandise exports) of Sub-Saharan Africa (all income levels) in 2004 to that in 2007?
Ensure brevity in your answer.  0.97. What is the ratio of the Imports(as % of merchandise exports) of El Salvador in 2004 to that in 2007?
Keep it short and to the point. 0.95. What is the ratio of the Imports(as % of merchandise exports) of Qatar in 2004 to that in 2007?
Provide a succinct answer. 1.59. What is the ratio of the Imports(as % of merchandise exports) of Middle East & North Africa (all income levels) in 2005 to that in 2006?
Provide a succinct answer. 1.03. What is the ratio of the Imports(as % of merchandise exports) of Sub-Saharan Africa (all income levels) in 2005 to that in 2006?
Make the answer very short. 0.91. What is the ratio of the Imports(as % of merchandise exports) of El Salvador in 2005 to that in 2006?
Offer a terse response. 1.01. What is the ratio of the Imports(as % of merchandise exports) in Qatar in 2005 to that in 2006?
Your answer should be very brief. 1.27. What is the ratio of the Imports(as % of merchandise exports) of Middle East & North Africa (all income levels) in 2005 to that in 2007?
Offer a very short reply. 0.99. What is the ratio of the Imports(as % of merchandise exports) in Sub-Saharan Africa (all income levels) in 2005 to that in 2007?
Keep it short and to the point. 0.89. What is the ratio of the Imports(as % of merchandise exports) in El Salvador in 2005 to that in 2007?
Your answer should be compact. 0.96. What is the ratio of the Imports(as % of merchandise exports) in Qatar in 2005 to that in 2007?
Offer a very short reply. 1.39. What is the ratio of the Imports(as % of merchandise exports) in Middle East & North Africa (all income levels) in 2006 to that in 2007?
Your response must be concise. 0.97. What is the ratio of the Imports(as % of merchandise exports) in Sub-Saharan Africa (all income levels) in 2006 to that in 2007?
Offer a very short reply. 0.98. What is the ratio of the Imports(as % of merchandise exports) of El Salvador in 2006 to that in 2007?
Make the answer very short. 0.94. What is the difference between the highest and the second highest Imports(as % of merchandise exports) of Middle East & North Africa (all income levels)?
Your response must be concise. 0.36. What is the difference between the highest and the second highest Imports(as % of merchandise exports) of Sub-Saharan Africa (all income levels)?
Offer a very short reply. 0.46. What is the difference between the highest and the second highest Imports(as % of merchandise exports) of El Salvador?
Offer a terse response. 0.64. What is the difference between the highest and the second highest Imports(as % of merchandise exports) in Qatar?
Make the answer very short. 2.02. What is the difference between the highest and the lowest Imports(as % of merchandise exports) in Middle East & North Africa (all income levels)?
Your response must be concise. 3. What is the difference between the highest and the lowest Imports(as % of merchandise exports) of Sub-Saharan Africa (all income levels)?
Offer a terse response. 2.85. What is the difference between the highest and the lowest Imports(as % of merchandise exports) in El Salvador?
Your answer should be very brief. 0.9. What is the difference between the highest and the lowest Imports(as % of merchandise exports) in Qatar?
Ensure brevity in your answer.  7.19. 